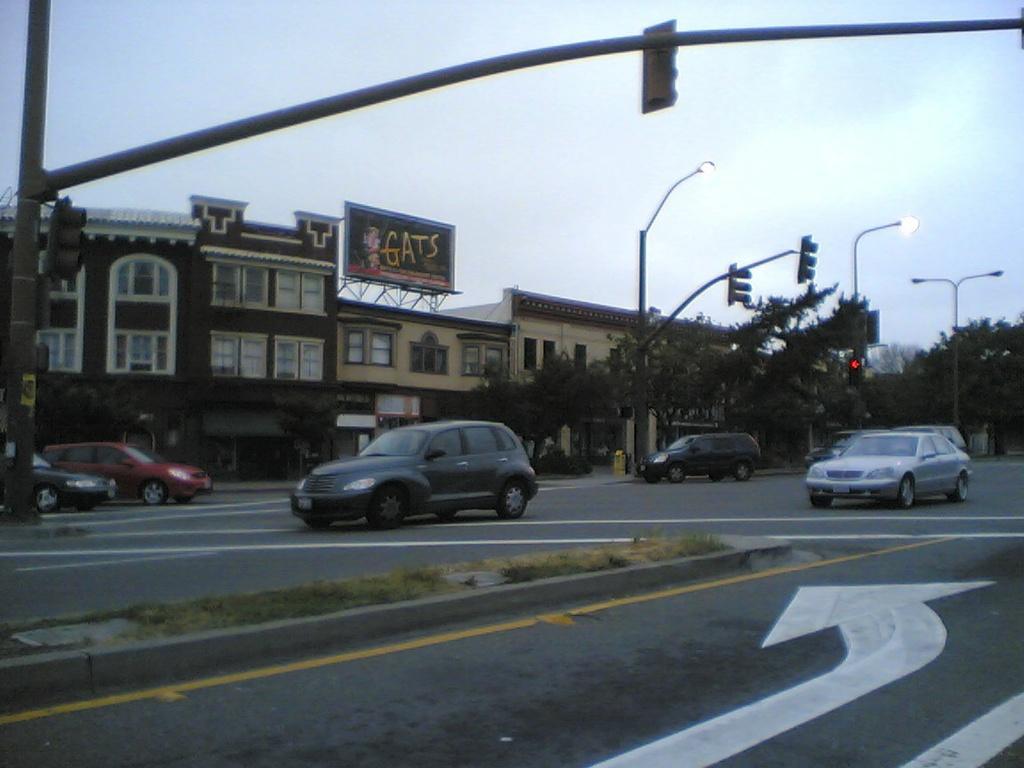Could you give a brief overview of what you see in this image? In this image I can see the road. On the road there are vehicles. To the side of the road there are many poles and trees. In the background I can see the board to the building. I can also see the sky in the back. 